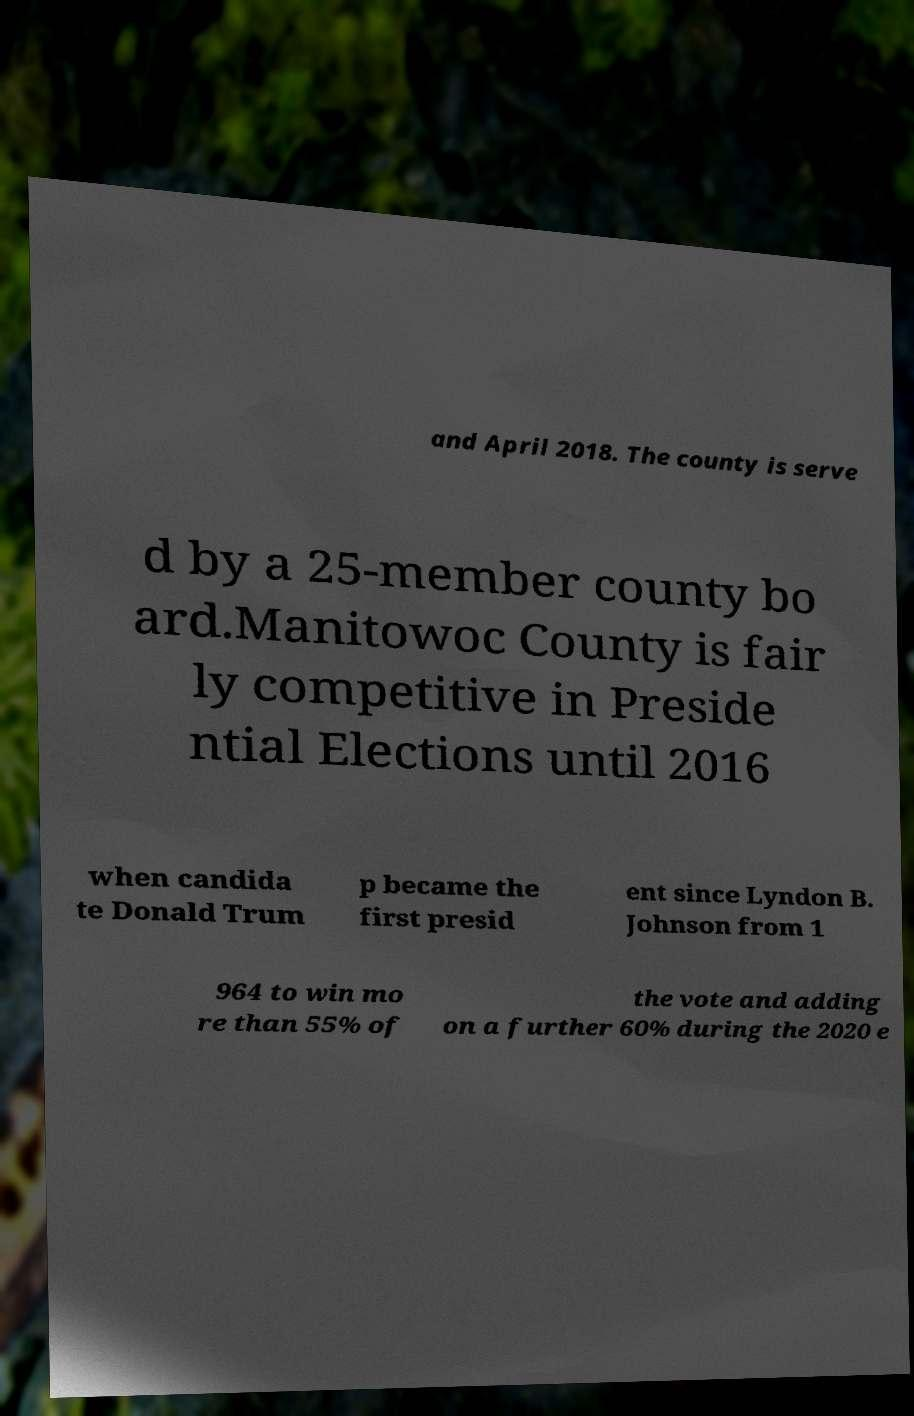Please read and relay the text visible in this image. What does it say? and April 2018. The county is serve d by a 25-member county bo ard.Manitowoc County is fair ly competitive in Preside ntial Elections until 2016 when candida te Donald Trum p became the first presid ent since Lyndon B. Johnson from 1 964 to win mo re than 55% of the vote and adding on a further 60% during the 2020 e 